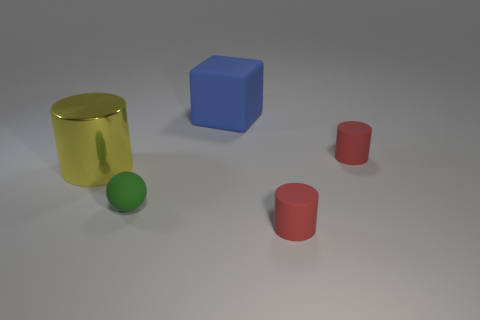How does the lighting in the image contribute to the overall composition? The lighting in the image appears to be coming from an upper left direction, casting soft shadows to the right of the objects. This directional lighting emphasizes the three-dimensionality of the objects, highlighting their forms and providing a sense of depth and texture in the composition. 